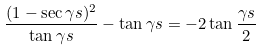<formula> <loc_0><loc_0><loc_500><loc_500>\frac { ( 1 - \sec \gamma s ) ^ { 2 } } { \tan \gamma s } - \tan \gamma s = - 2 \tan \frac { \gamma s } { 2 }</formula> 